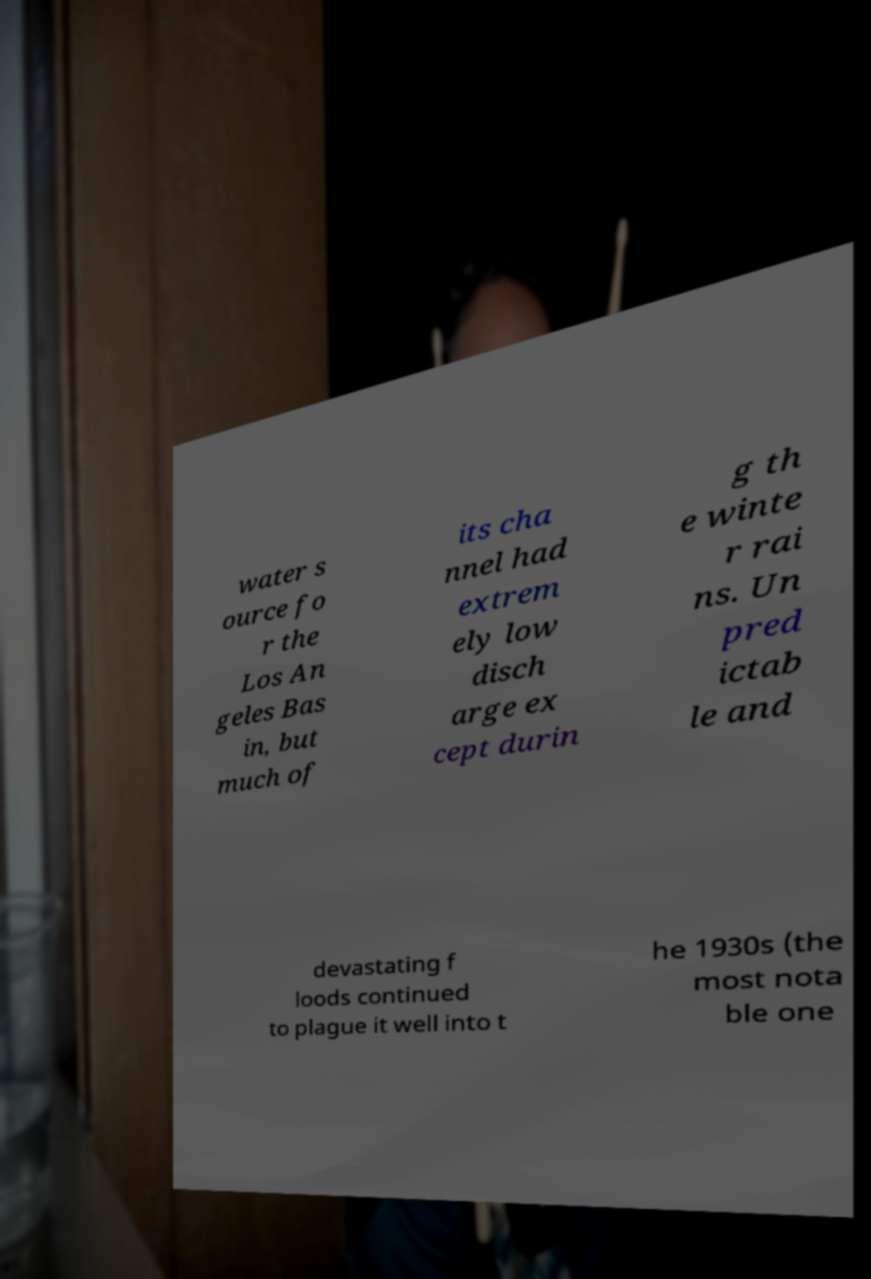Could you extract and type out the text from this image? water s ource fo r the Los An geles Bas in, but much of its cha nnel had extrem ely low disch arge ex cept durin g th e winte r rai ns. Un pred ictab le and devastating f loods continued to plague it well into t he 1930s (the most nota ble one 